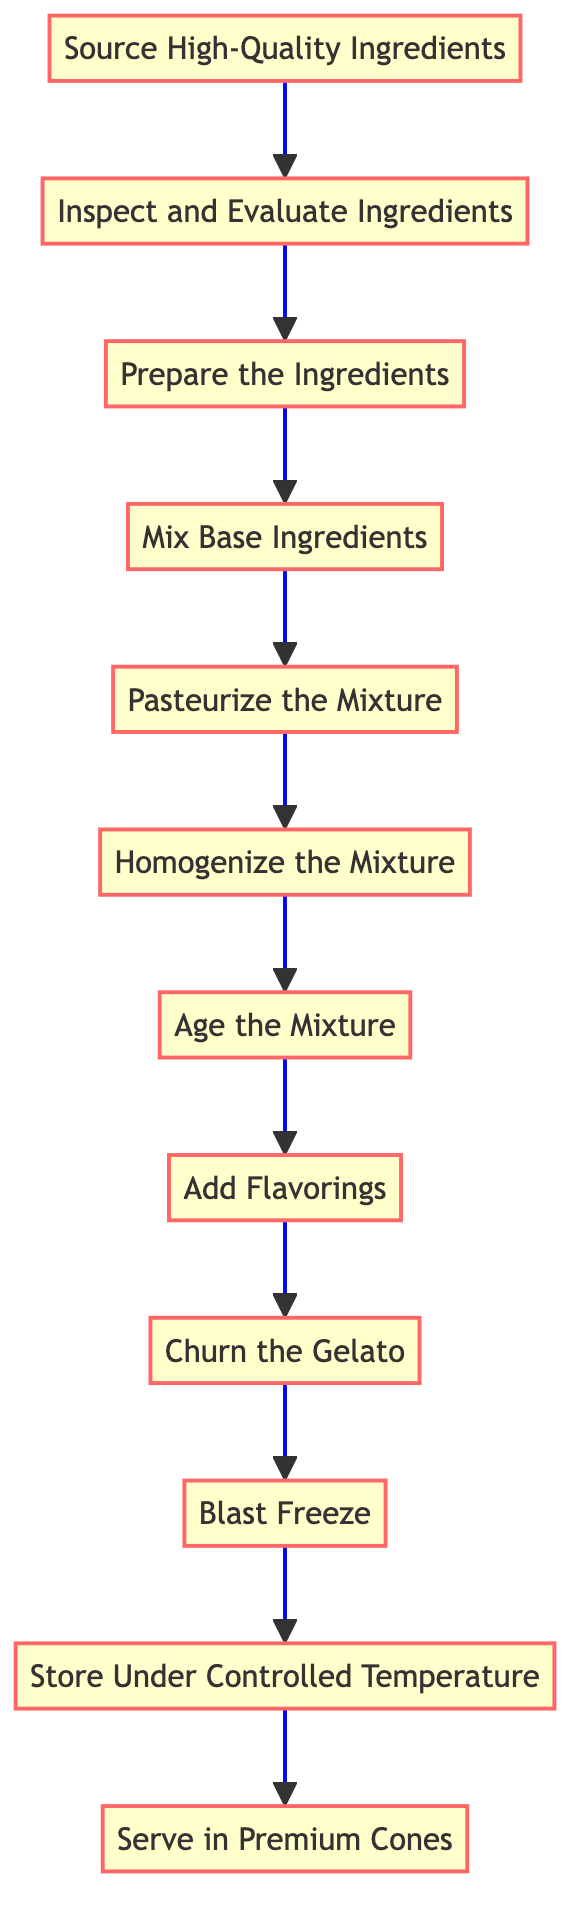What is the first step in ensuring gelato quality? The first step is shown at the bottom of the flow chart, which is "Source High-Quality Ingredients." This indicates the initial action to begin the process.
Answer: Source High-Quality Ingredients How many total steps are in the process? By counting the steps listed in the flow chart, there are a total of 12 distinct phases outlined from sourcing ingredients to serving the gelato.
Answer: 12 What step comes after "Pasteurize the Mixture"? The diagram indicates that "Homogenize the Mixture" follows "Pasteurize the Mixture," as it is directly connected to it in the upward flow.
Answer: Homogenize the Mixture Which step includes introducing natural flavorings? The flow chart specifies "Add Flavorings" as the step where natural flavorings are incorporated into the gelato mixture.
Answer: Add Flavorings What is the last step in the gelato-making process? The final step at the top of the flow chart is "Serve in Premium Cones," which signifies the end of the quality assurance process before presenting the gelato.
Answer: Serve in Premium Cones Which step is immediately before "Churn the Gelato"? From the flow chart, the step that immediately precedes "Churn the Gelato" is "Add Flavorings," indicating the process must include flavorings before churning.
Answer: Add Flavorings What process step requires the gelato mix to rest in a cold room? The flow chart identifies "Age the Mixture" as the step where the gelato mix is allowed to rest to enhance its flavor and texture.
Answer: Age the Mixture Which two steps focus on ensuring the texture of the gelato? The steps "Homogenize the Mixture" and "Churn the Gelato" both focus on achieving a smooth texture and incorporating air for creaminess, thus enhancing the gelato's mouthfeel.
Answer: Homogenize the Mixture; Churn the Gelato What is required to maintain gelato quality during storage? The flow chart specifies "Store Under Controlled Temperature" to maintain the gelato's quality until it is ready to be served, indicating the need to keep it at -18°C.
Answer: Store Under Controlled Temperature 